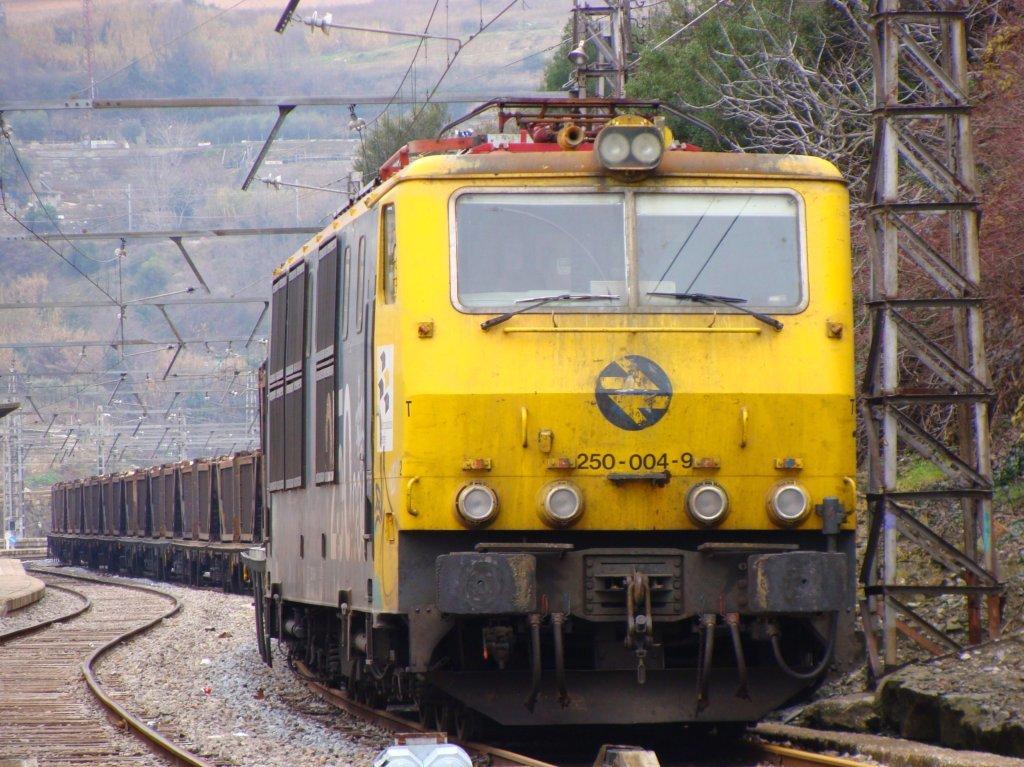What number is seen on the front?
Provide a short and direct response. 250-004-9. 